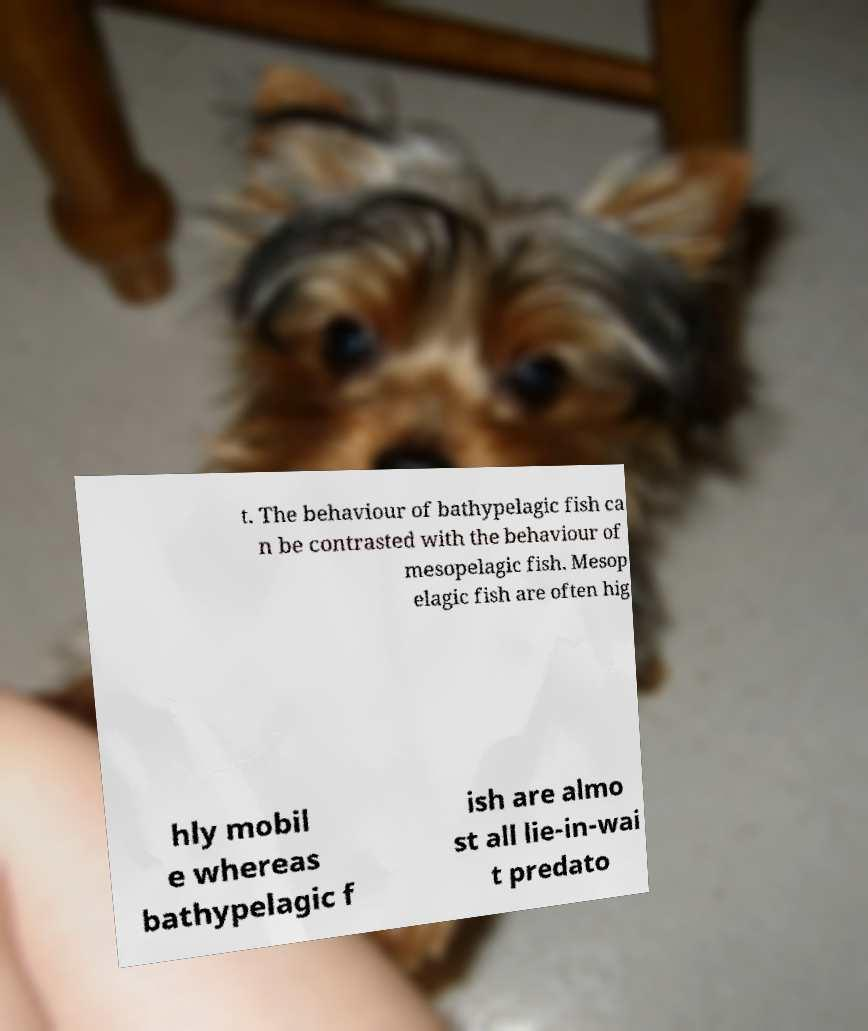Can you accurately transcribe the text from the provided image for me? t. The behaviour of bathypelagic fish ca n be contrasted with the behaviour of mesopelagic fish. Mesop elagic fish are often hig hly mobil e whereas bathypelagic f ish are almo st all lie-in-wai t predato 